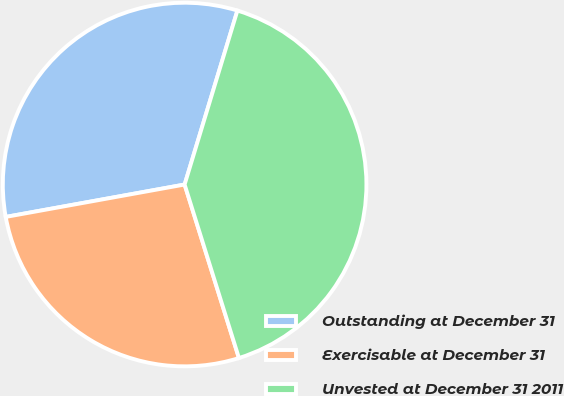<chart> <loc_0><loc_0><loc_500><loc_500><pie_chart><fcel>Outstanding at December 31<fcel>Exercisable at December 31<fcel>Unvested at December 31 2011<nl><fcel>32.54%<fcel>26.98%<fcel>40.48%<nl></chart> 